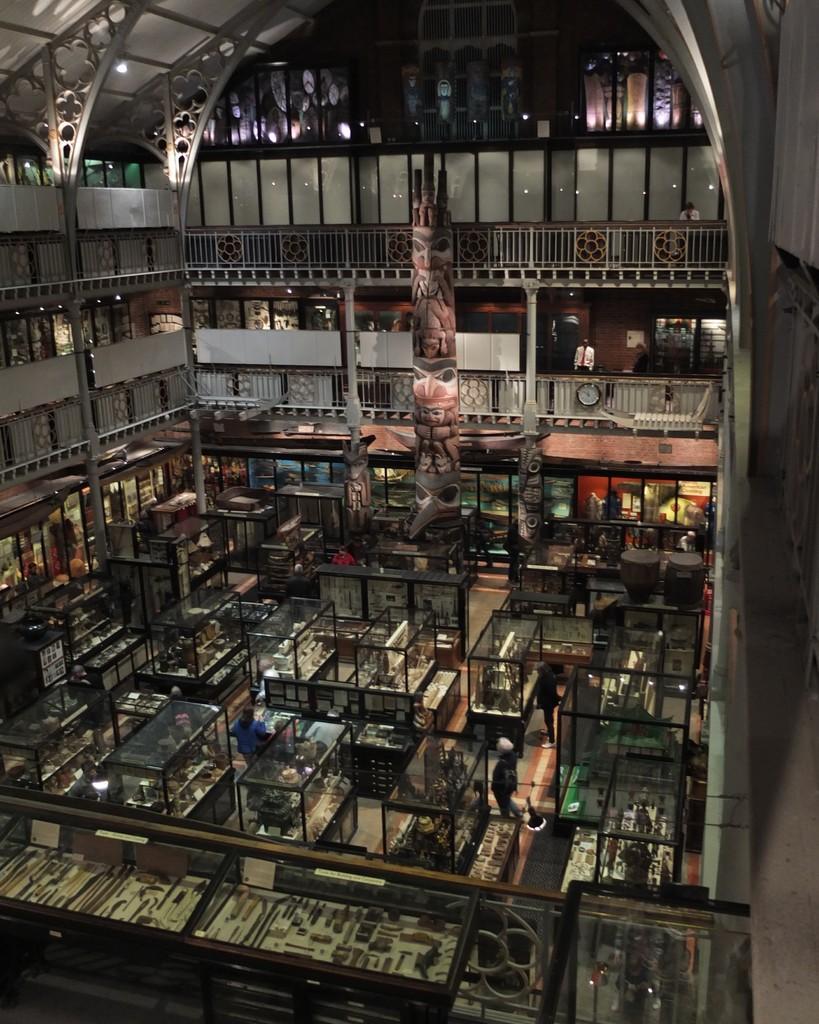Describe this image in one or two sentences. In this image, we can see an inside view of a building. There are three persons standing and wearing clothes. There are glass boxes in the middle of the image. 